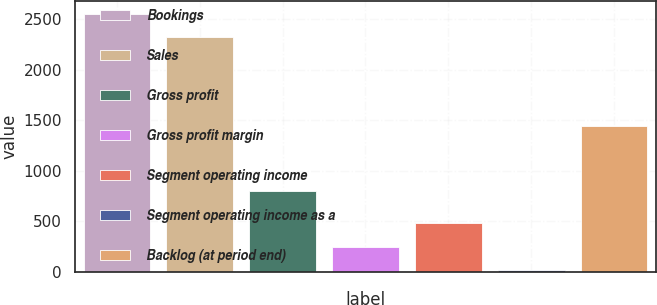<chart> <loc_0><loc_0><loc_500><loc_500><bar_chart><fcel>Bookings<fcel>Sales<fcel>Gross profit<fcel>Gross profit margin<fcel>Segment operating income<fcel>Segment operating income as a<fcel>Backlog (at period end)<nl><fcel>2553.05<fcel>2321.4<fcel>803.4<fcel>248.65<fcel>480.3<fcel>17<fcel>1441.6<nl></chart> 